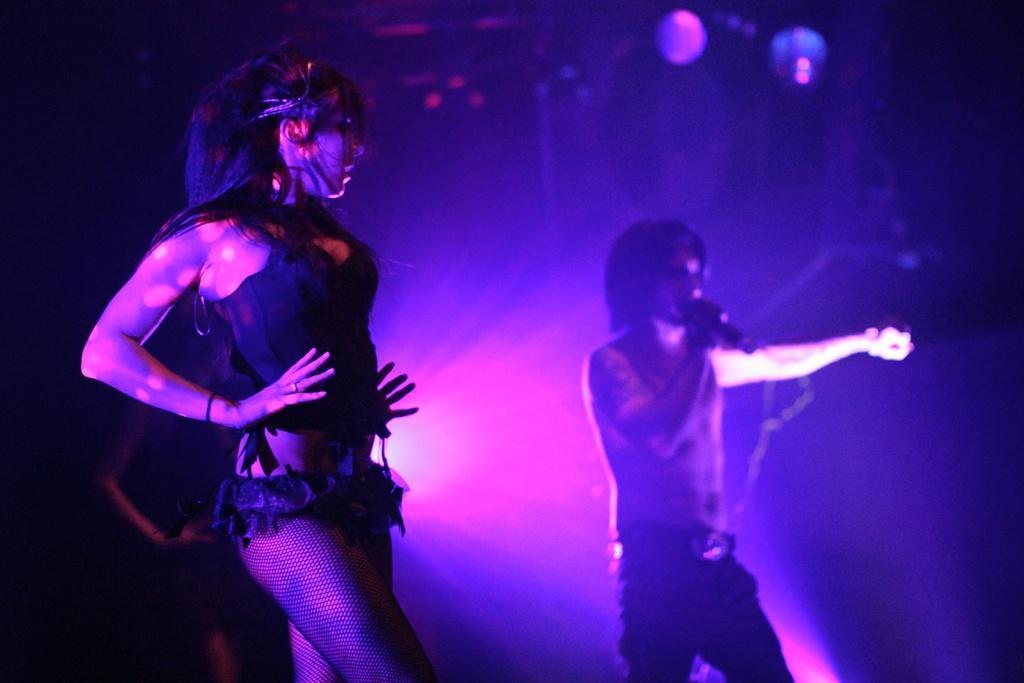How would you summarize this image in a sentence or two? On the left side of the image few persons are standing and dancing. On the right side of the image a person is standing and holding a microphone. 